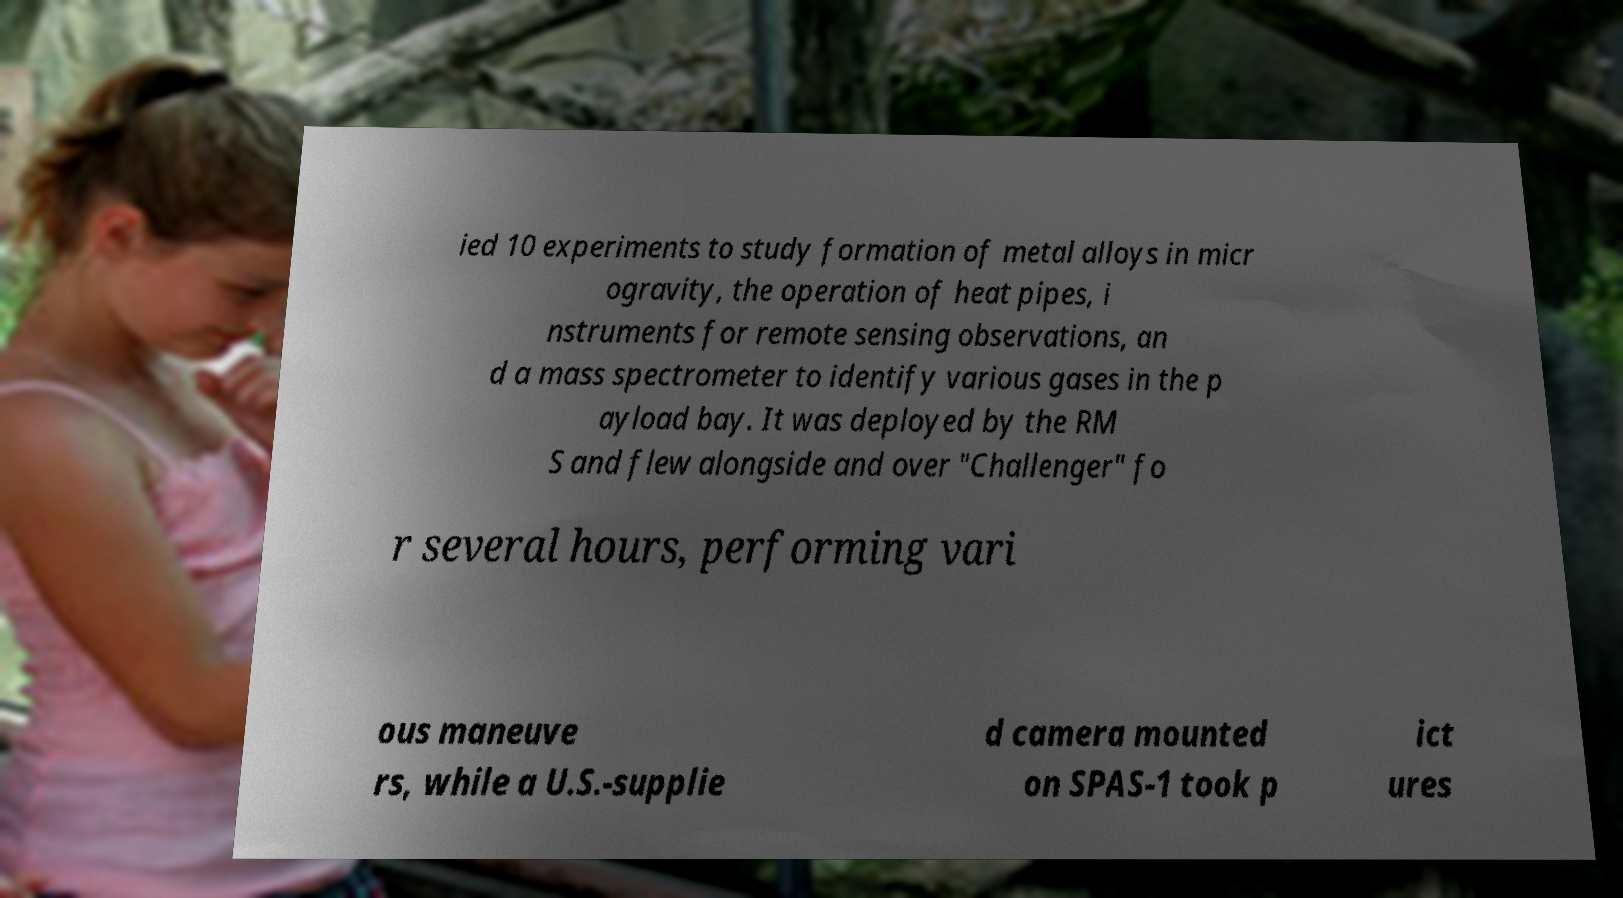Could you assist in decoding the text presented in this image and type it out clearly? ied 10 experiments to study formation of metal alloys in micr ogravity, the operation of heat pipes, i nstruments for remote sensing observations, an d a mass spectrometer to identify various gases in the p ayload bay. It was deployed by the RM S and flew alongside and over "Challenger" fo r several hours, performing vari ous maneuve rs, while a U.S.-supplie d camera mounted on SPAS-1 took p ict ures 